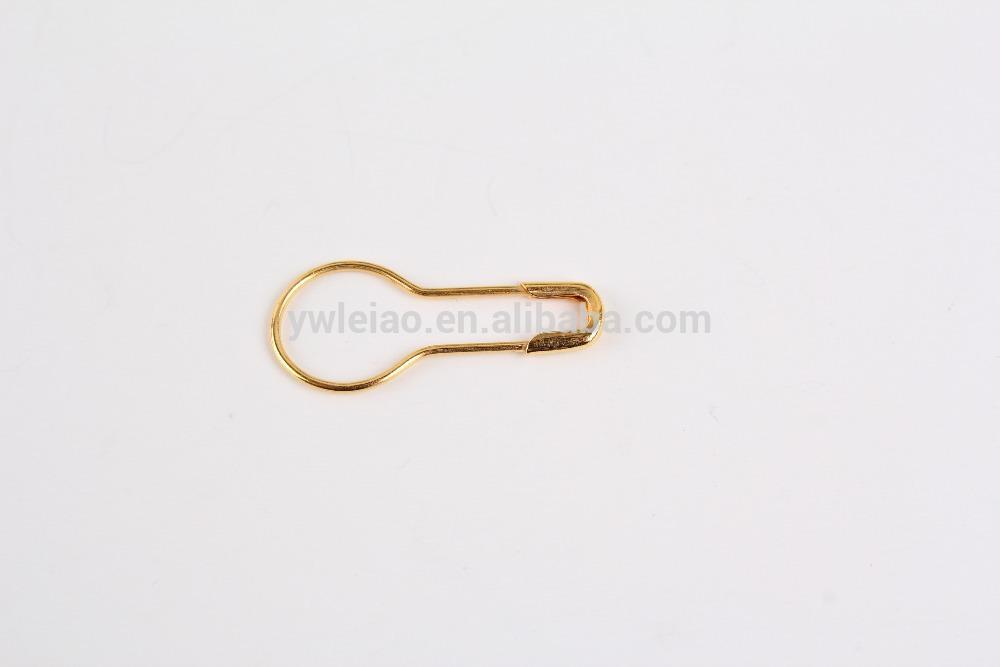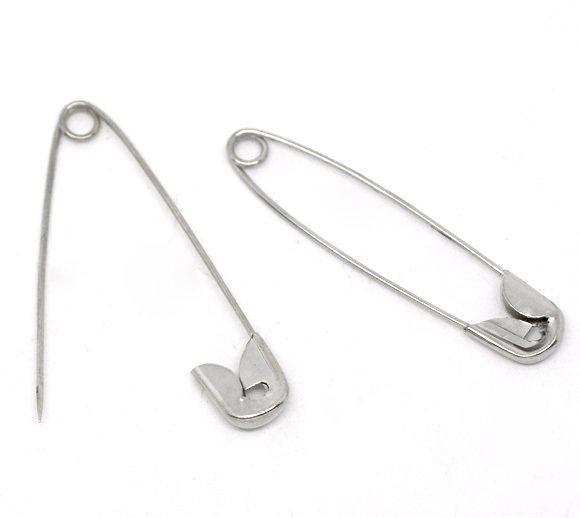The first image is the image on the left, the second image is the image on the right. For the images shown, is this caption "In at least one image the clip is not silver at all." true? Answer yes or no. Yes. 